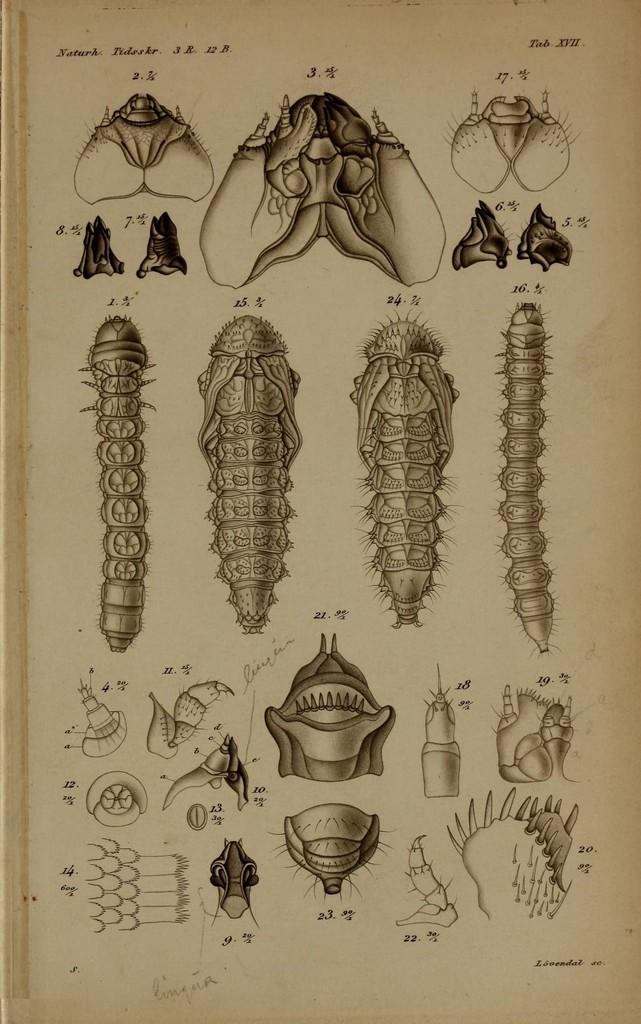What is present in the image? There is a paper in the image. What is depicted on the paper? The paper contains pictures of insects. What type of frame is used to display the paint on the paper? There is no paint present on the paper, only pictures of insects. The paper does not have a frame, as it is a flat sheet. 